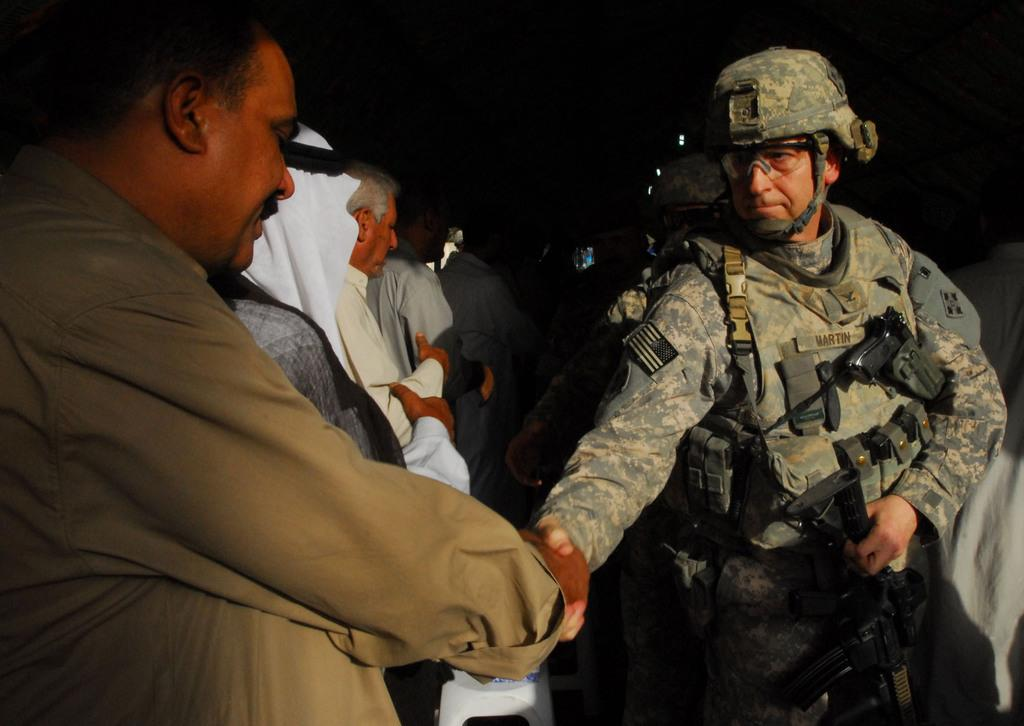How many people are in the foreground of the image? There are two men in the foreground of the image. What are the two men doing in the image? The two men are shaking hands. Can you describe the people in the background of the image? There are persons standing in the background of the image. What is the color of the background in the image? The background is dark. What type of machine can be seen in the background of the image? There is no machine present in the image. How many eggs are visible on the table in the image? There is no table or eggs present in the image. 